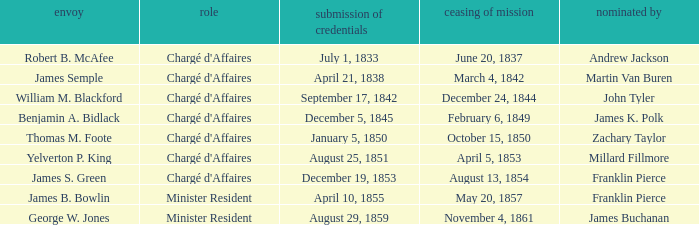Which Title has an Appointed by of Millard Fillmore? Chargé d'Affaires. Could you parse the entire table as a dict? {'header': ['envoy', 'role', 'submission of credentials', 'ceasing of mission', 'nominated by'], 'rows': [['Robert B. McAfee', "Chargé d'Affaires", 'July 1, 1833', 'June 20, 1837', 'Andrew Jackson'], ['James Semple', "Chargé d'Affaires", 'April 21, 1838', 'March 4, 1842', 'Martin Van Buren'], ['William M. Blackford', "Chargé d'Affaires", 'September 17, 1842', 'December 24, 1844', 'John Tyler'], ['Benjamin A. Bidlack', "Chargé d'Affaires", 'December 5, 1845', 'February 6, 1849', 'James K. Polk'], ['Thomas M. Foote', "Chargé d'Affaires", 'January 5, 1850', 'October 15, 1850', 'Zachary Taylor'], ['Yelverton P. King', "Chargé d'Affaires", 'August 25, 1851', 'April 5, 1853', 'Millard Fillmore'], ['James S. Green', "Chargé d'Affaires", 'December 19, 1853', 'August 13, 1854', 'Franklin Pierce'], ['James B. Bowlin', 'Minister Resident', 'April 10, 1855', 'May 20, 1857', 'Franklin Pierce'], ['George W. Jones', 'Minister Resident', 'August 29, 1859', 'November 4, 1861', 'James Buchanan']]} 